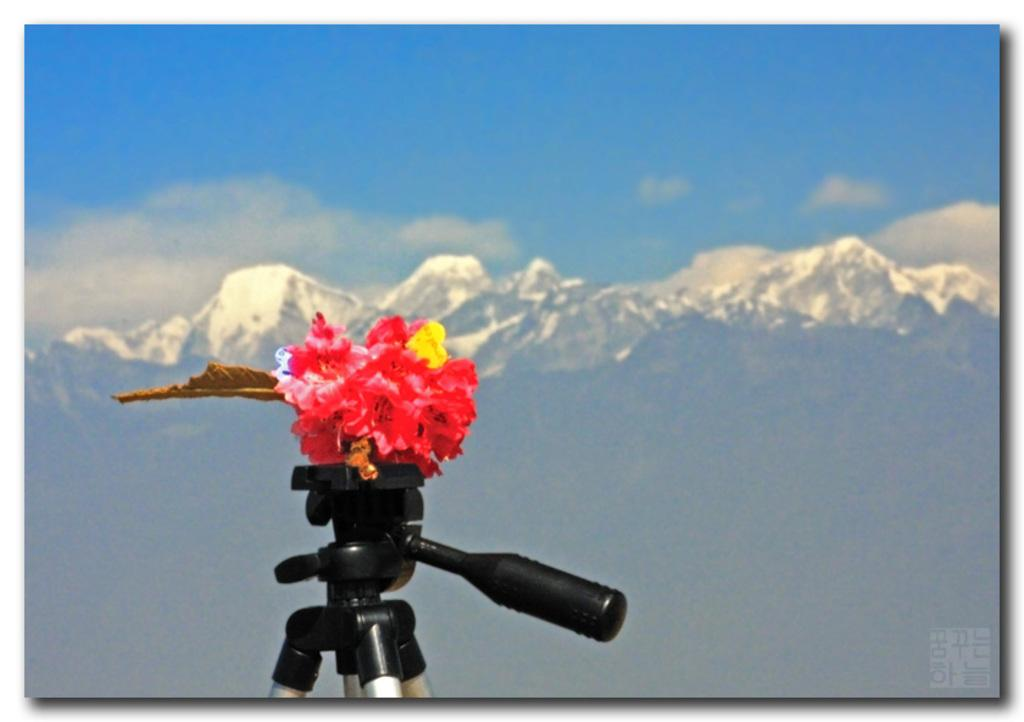What type of plants can be seen in the image? There are flowers in the image. What part of a plant is also visible in the image? There is a leaf in the image. How are the flowers and leaf positioned in the image? The flowers and leaf are on a tripod. What can be seen in the distance in the image? There are mountains in the background of the image. How would you describe the sky in the image? The sky is blue and cloudy in the image. What word is written on the girl's shirt in the image? There is no girl present in the image, so it is not possible to answer that question. 